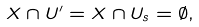<formula> <loc_0><loc_0><loc_500><loc_500>X \cap U ^ { \prime } = X \cap U _ { s } = \emptyset ,</formula> 